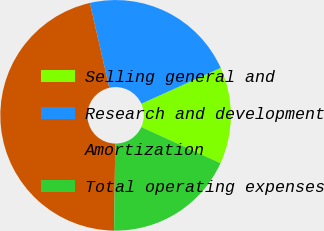<chart> <loc_0><loc_0><loc_500><loc_500><pie_chart><fcel>Selling general and<fcel>Research and development<fcel>Amortization<fcel>Total operating expenses<nl><fcel>13.57%<fcel>21.83%<fcel>46.21%<fcel>18.39%<nl></chart> 